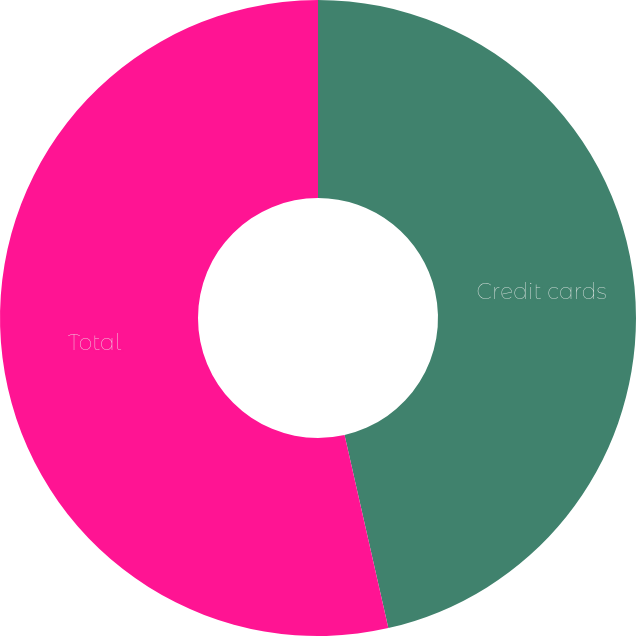Convert chart. <chart><loc_0><loc_0><loc_500><loc_500><pie_chart><fcel>Credit cards<fcel>Total<nl><fcel>46.45%<fcel>53.55%<nl></chart> 